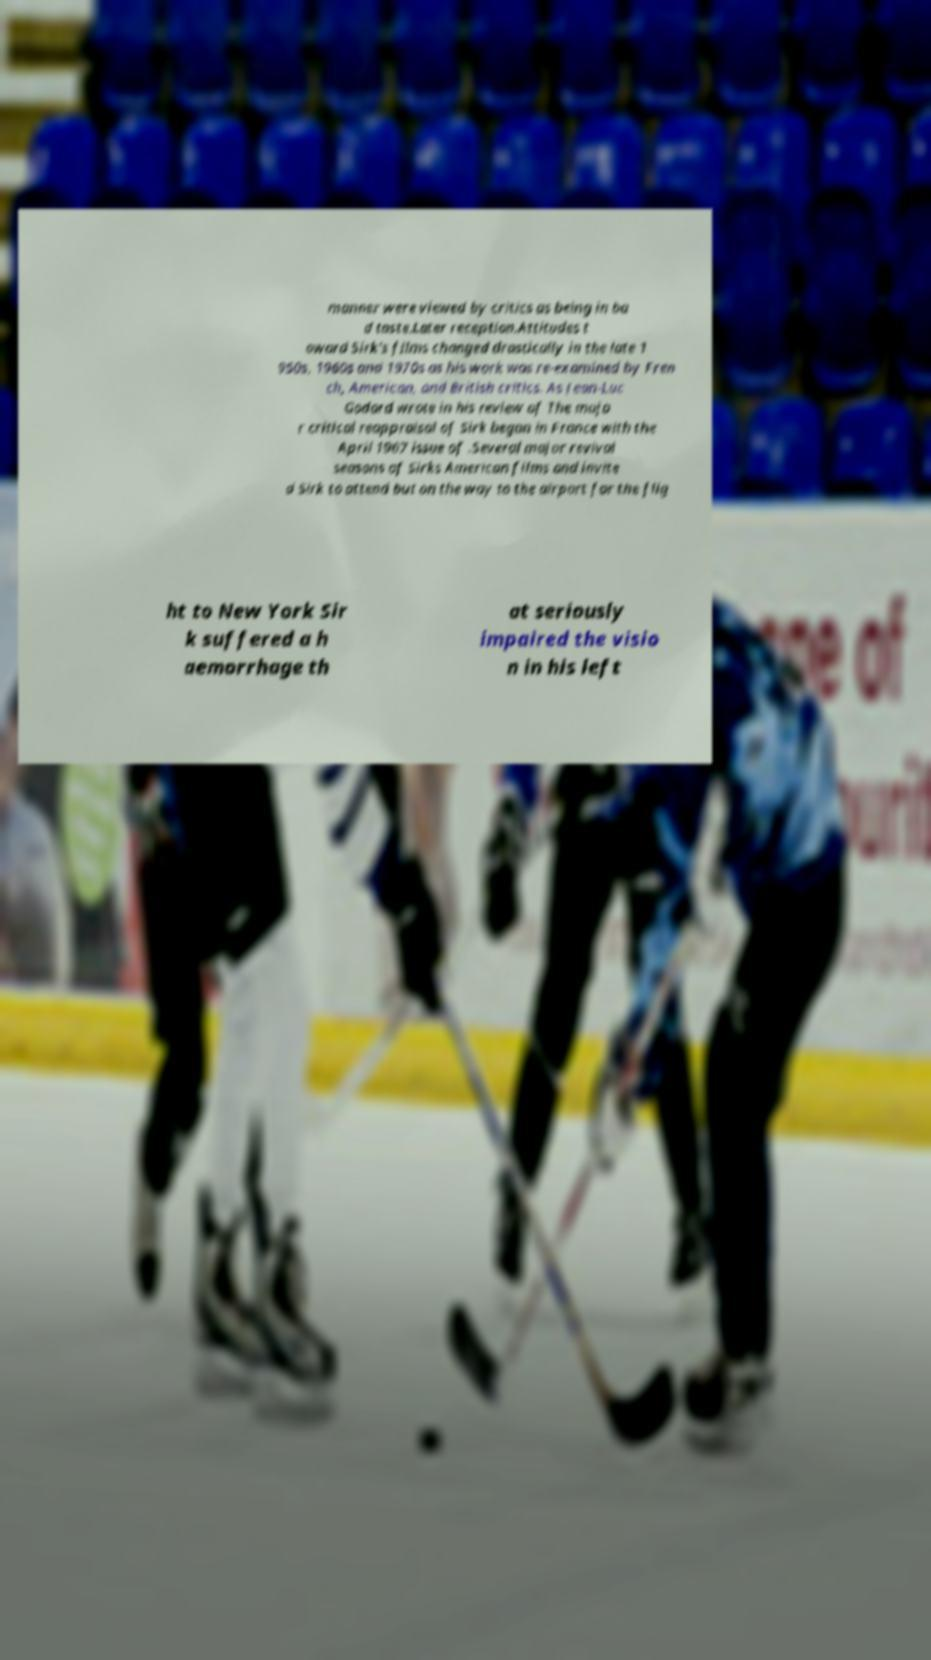Can you read and provide the text displayed in the image?This photo seems to have some interesting text. Can you extract and type it out for me? manner were viewed by critics as being in ba d taste.Later reception.Attitudes t oward Sirk's films changed drastically in the late 1 950s, 1960s and 1970s as his work was re-examined by Fren ch, American, and British critics. As Jean-Luc Godard wrote in his review of The majo r critical reappraisal of Sirk began in France with the April 1967 issue of .Several major revival seasons of Sirks American films and invite d Sirk to attend but on the way to the airport for the flig ht to New York Sir k suffered a h aemorrhage th at seriously impaired the visio n in his left 